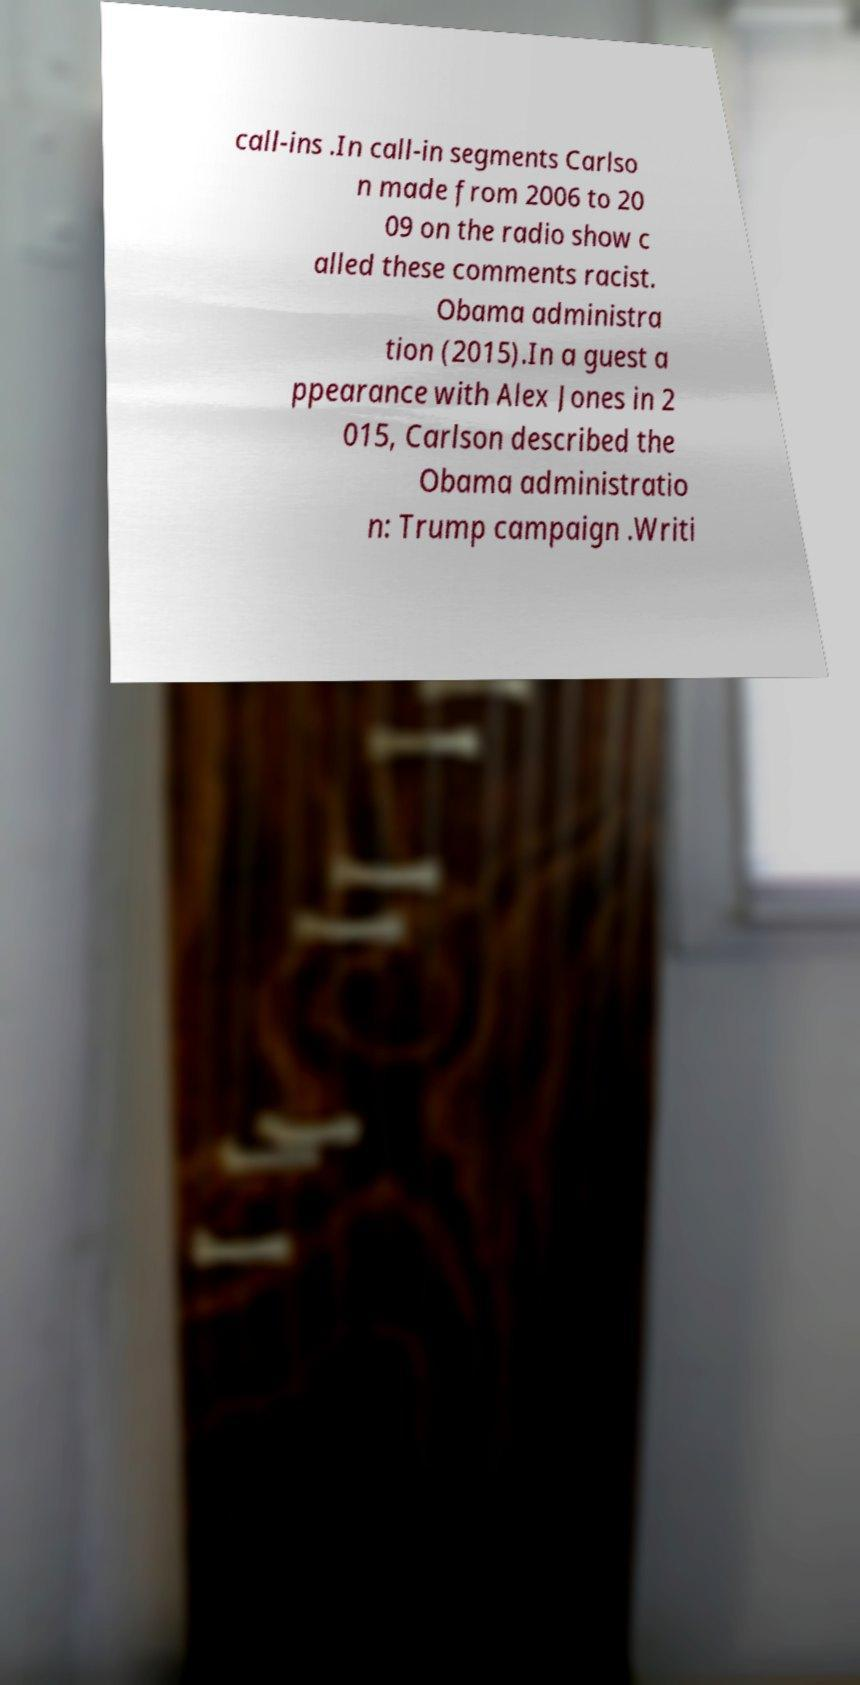Please read and relay the text visible in this image. What does it say? call-ins .In call-in segments Carlso n made from 2006 to 20 09 on the radio show c alled these comments racist. Obama administra tion (2015).In a guest a ppearance with Alex Jones in 2 015, Carlson described the Obama administratio n: Trump campaign .Writi 